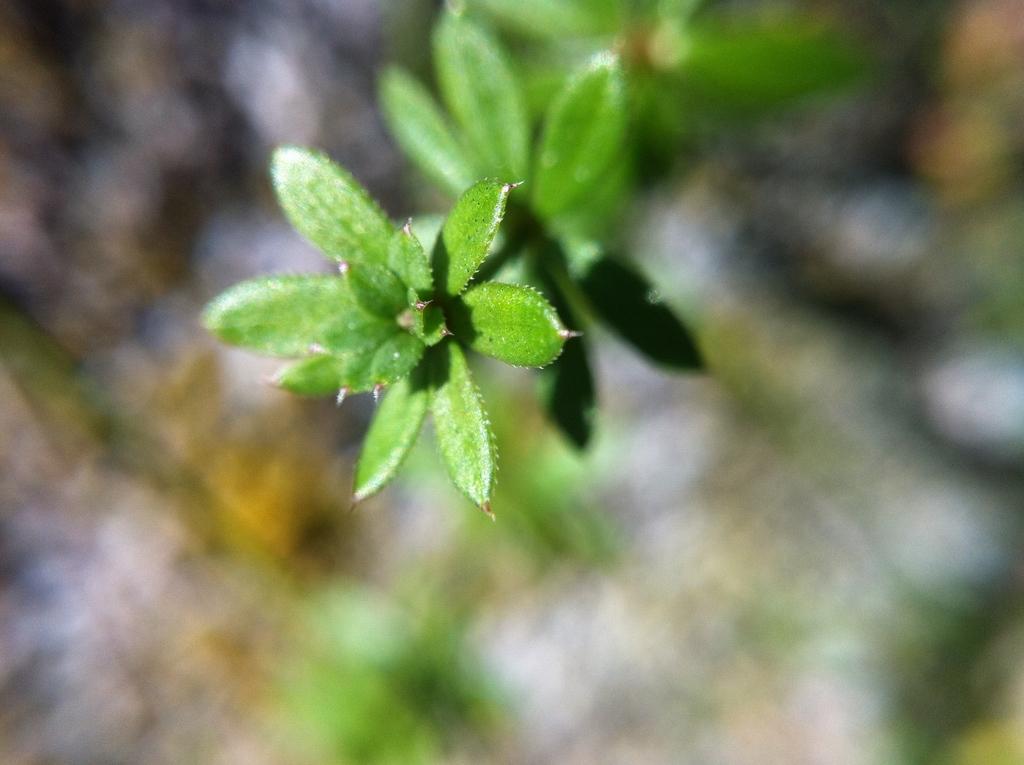How would you summarize this image in a sentence or two? In this image I can see a plant which is green in color and the blurry background. 